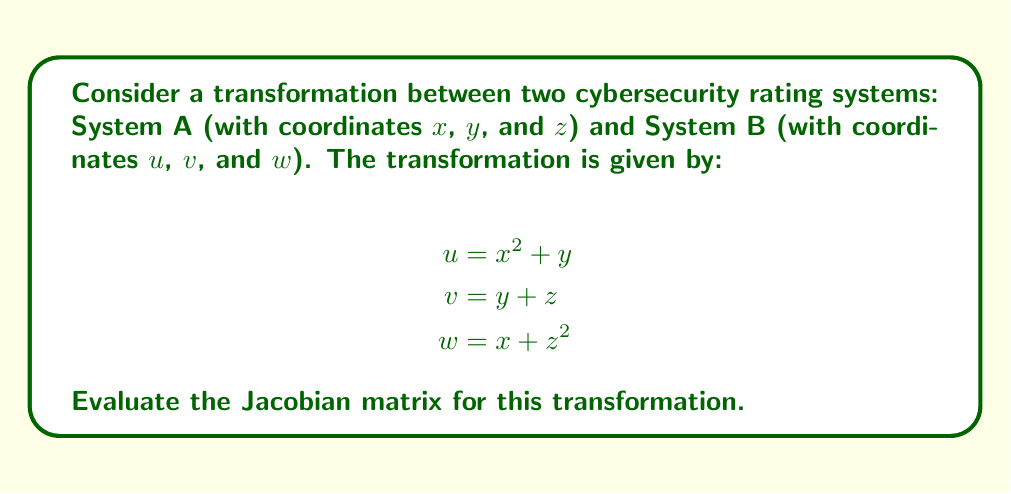Teach me how to tackle this problem. To evaluate the Jacobian matrix, we need to calculate the partial derivatives of each output coordinate with respect to each input coordinate. The Jacobian matrix is a 3x3 matrix in this case:

$$J = \begin{bmatrix}
\frac{\partial u}{\partial x} & \frac{\partial u}{\partial y} & \frac{\partial u}{\partial z} \\
\frac{\partial v}{\partial x} & \frac{\partial v}{\partial y} & \frac{\partial v}{\partial z} \\
\frac{\partial w}{\partial x} & \frac{\partial w}{\partial y} & \frac{\partial w}{\partial z}
\end{bmatrix}$$

Let's calculate each partial derivative:

1. $\frac{\partial u}{\partial x} = 2x$
2. $\frac{\partial u}{\partial y} = 1$
3. $\frac{\partial u}{\partial z} = 0$
4. $\frac{\partial v}{\partial x} = 0$
5. $\frac{\partial v}{\partial y} = 1$
6. $\frac{\partial v}{\partial z} = 1$
7. $\frac{\partial w}{\partial x} = 1$
8. $\frac{\partial w}{\partial y} = 0$
9. $\frac{\partial w}{\partial z} = 2z$

Now, we can fill in the Jacobian matrix with these partial derivatives:

$$J = \begin{bmatrix}
2x & 1 & 0 \\
0 & 1 & 1 \\
1 & 0 & 2z
\end{bmatrix}$$

This is the Jacobian matrix for the given transformation between the two cybersecurity rating systems.
Answer: $$J = \begin{bmatrix}
2x & 1 & 0 \\
0 & 1 & 1 \\
1 & 0 & 2z
\end{bmatrix}$$ 